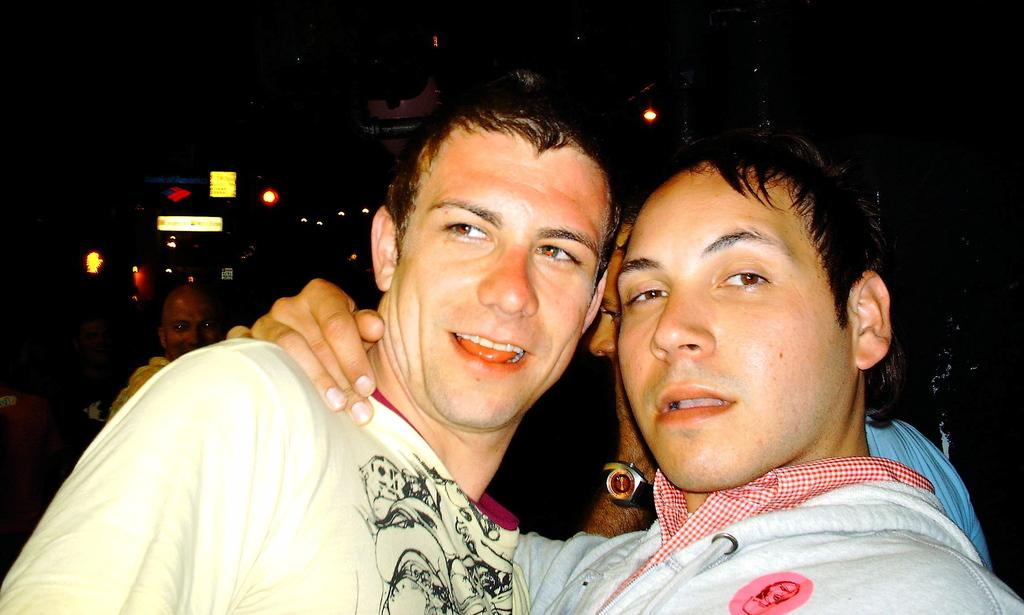How many men are in the image? There are two men in the image. Can you describe the background of the image? The background of the image is dark, and there are a few people and some lights visible. Are there any other individuals besides the two men in the image? Yes, there are a few people in the background of the image. What type of milk is being poured into the channel in the image? There is no milk or channel present in the image. What kind of fowl can be seen in the image? There are no fowl present in the image. 